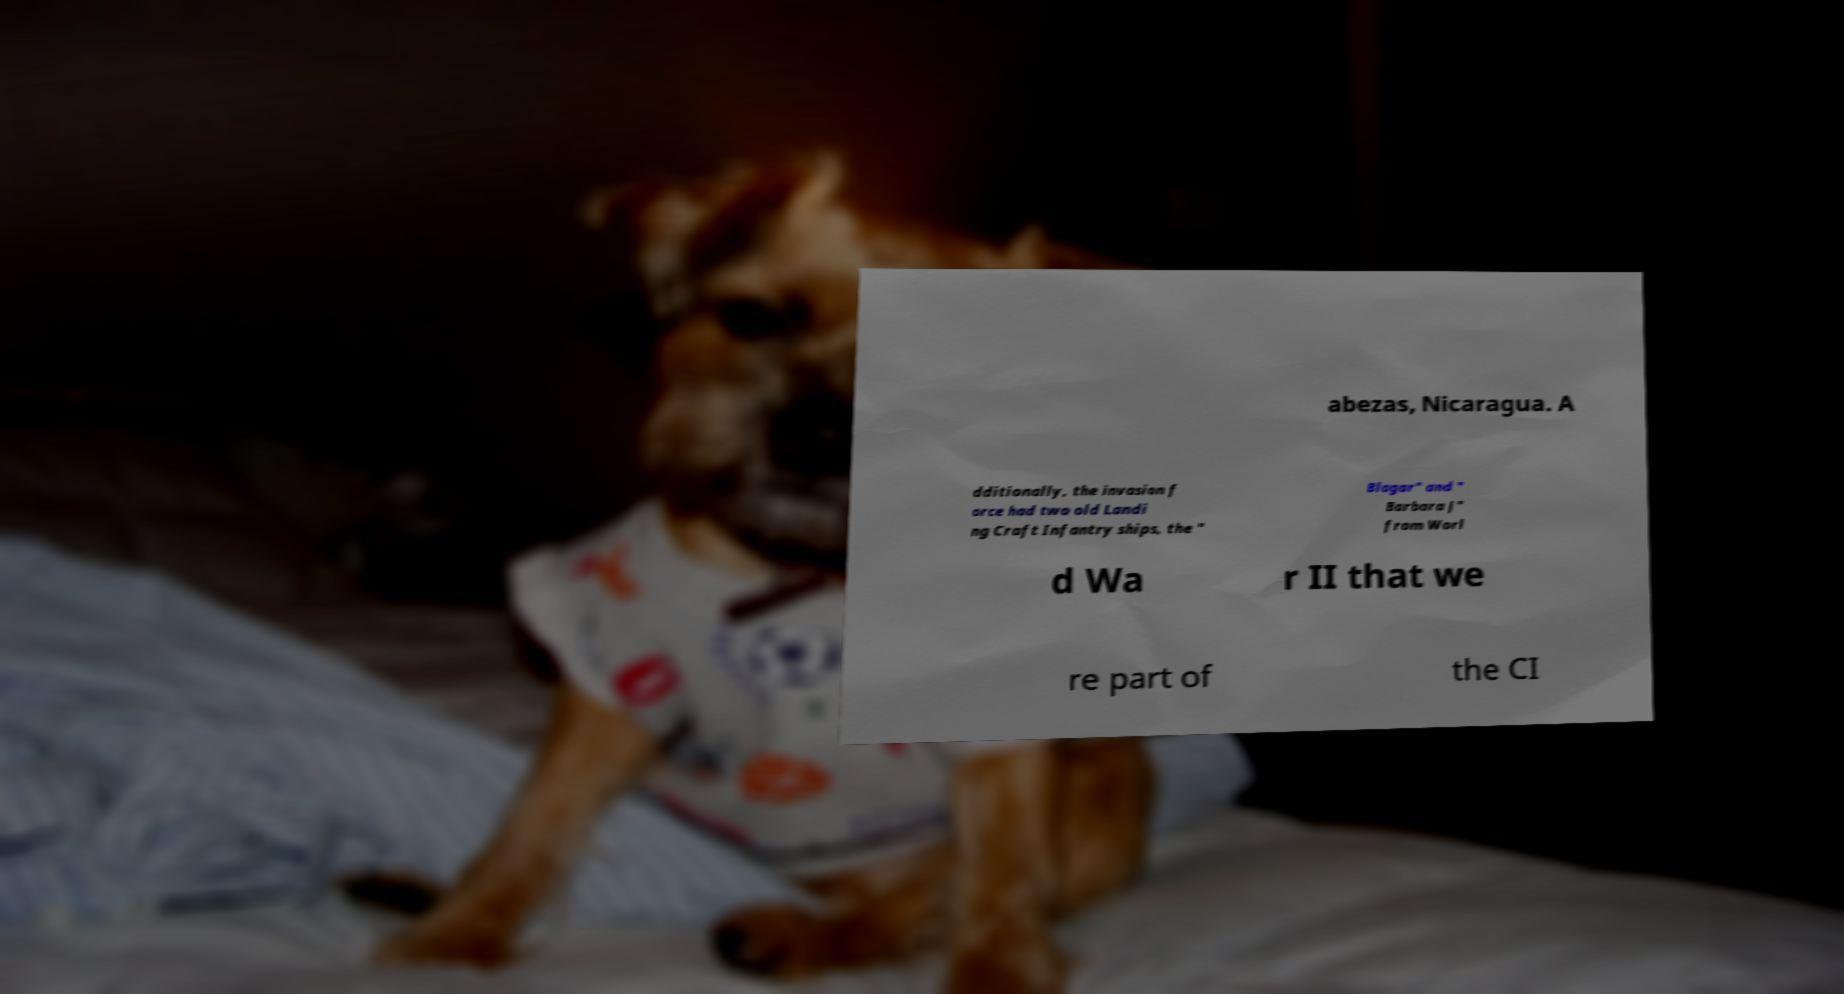Could you assist in decoding the text presented in this image and type it out clearly? abezas, Nicaragua. A dditionally, the invasion f orce had two old Landi ng Craft Infantry ships, the " Blagar" and " Barbara J" from Worl d Wa r II that we re part of the CI 